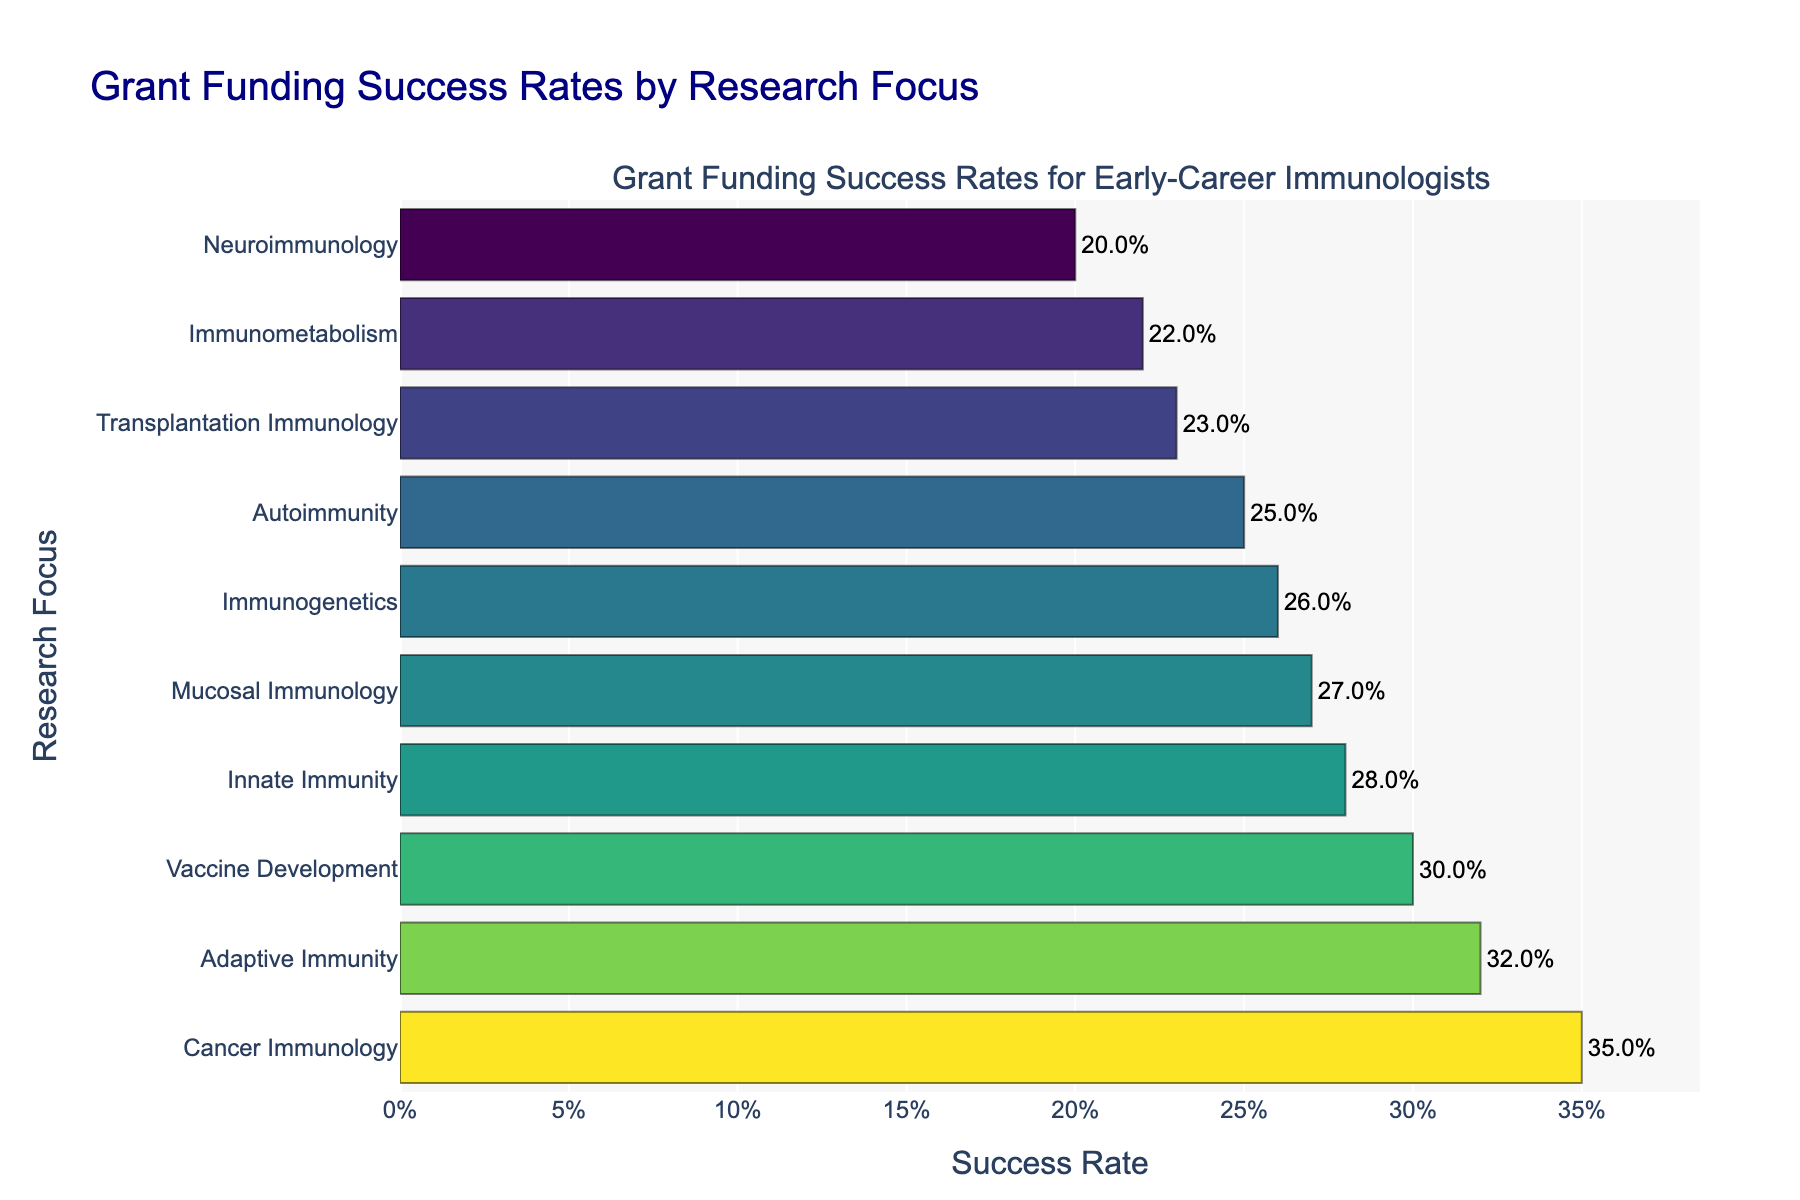Why does Maharashtra consistently have the highest enrollment in the Marathi language preservation programs from 2018-2021? Based on the figure, Maharashtra shows the highest number of enrollments for Marathi each year. This suggests a strong regional focus, likely due to Marathi being the official language and of significant cultural heritage in Maharashtra.
Answer: Marathi is the main language in Maharashtra Which language program shows the most significant increase in enrollments in Tamil Nadu from 2018 to 2021? Observing the figure for Tamil Nadu across the years, Telugu consistently rises from 150 in 2018 to 210 in 2021. This steady upward trend signifies the largest increase among the languages in Tamil Nadu.
Answer: Telugu How do the enrollments in Sanskrit programs across all states change from 2018 to 2021? Enrollments for Sanskrit have shown a general increase in all states: Maharashtra (120 to 165), Tamil Nadu (85 to 115), Kerala (60 to 90), West Bengal (110 to 155), Punjab (45 to 75). Each state shows a steady climb in numbers.
Answer: General increase Compare the trends for Bengali language enrollments between Punjab and West Bengal. What can you infer? The figure shows that Bengal enrollments in West Bengal increase steadily from 180 in 2018 to 240 in 2021, while in Punjab, the increase is from 10 in 2018 to 25 in 2021. West Bengal, being the home state for the Bengali language, has much higher enrollments overall.
Answer: West Bengal has significantly higher enrollments What is the trend for Pali language enrollments in Kerala? The figure shows that enrollments for Pali in Kerala rise gradually from 25 in 2018 to 40 in 2021. This indicates a steady but modest increase in interest or efforts in Pali language preservation.
Answer: Steady increase Calculate the average enrollments for Telugu programs across all states and years. To find the average: Sum the total enrollments for Telugu: (80+90+100+110) + (150+170+190+210) + (40+45+50+55) + (30+35+40+45) + (15+20+25+30) = 1500. Divide by 4 years and 5 states: 1500 / (4*5) = 75
Answer: 75 Which state's enrollment showed the least variation for Sanskrit from 2018 to 2021? To determine the least variation, observe the values for each state in the Sanskrit subplots: Maharashtra (120-165), Tamil Nadu (85-115), Kerala (60-90), West Bengal (110-155), Punjab (45-75). Kerala shows the least increase between the minimum and maximum enrollments (30).
Answer: Kerala Which state has the lowest overall enrollments for all languages combined over the four years? Sum the enrollments for each state for all years and languages. Punjab generally shows lower enrollment numbers across all languages compared to the other states.
Answer: Punjab What can you deduce about the region with the highest enrollment in Marathi programs? Maharashtra consistently shows the highest enrollments for Marathi programs every year, indicating strong regional engagement and efforts in preserving the language.
Answer: Maharashtra How do the trends in enrollments for Pali in Tamil Nadu compare to those in Kerala? Comparing Tamil Nadu to Kerala, Pali enrollments in Tamil Nadu increase from 30 in 2018 to 45 in 2021. Kerala also sees an increase from 25 in 2018 to 40 in 2021 but appears to consistently have slightly lower enrollments than Tamil Nadu.
Answer: Tamil Nadu slightly higher 